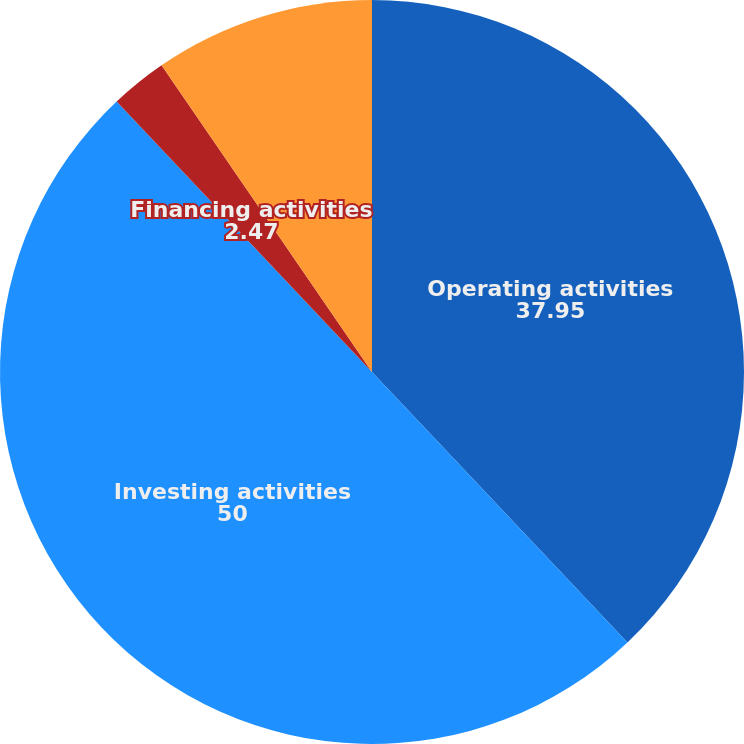<chart> <loc_0><loc_0><loc_500><loc_500><pie_chart><fcel>Operating activities<fcel>Investing activities<fcel>Financing activities<fcel>Net increase (decrease) in<nl><fcel>37.95%<fcel>50.0%<fcel>2.47%<fcel>9.57%<nl></chart> 